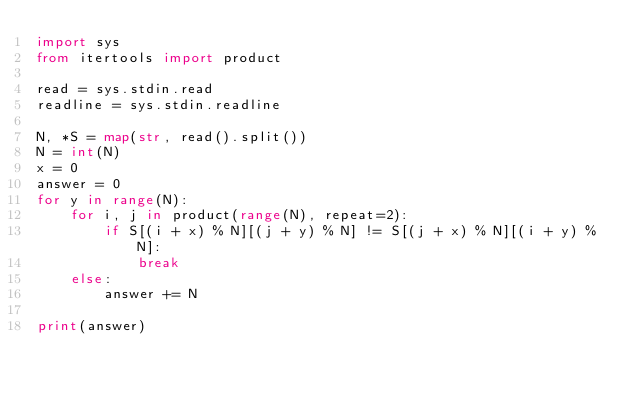<code> <loc_0><loc_0><loc_500><loc_500><_Python_>import sys
from itertools import product

read = sys.stdin.read
readline = sys.stdin.readline

N, *S = map(str, read().split())
N = int(N)
x = 0
answer = 0
for y in range(N):
    for i, j in product(range(N), repeat=2):
        if S[(i + x) % N][(j + y) % N] != S[(j + x) % N][(i + y) % N]:
            break
    else:
        answer += N

print(answer)
</code> 